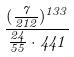<formula> <loc_0><loc_0><loc_500><loc_500>\frac { ( \frac { 7 } { 2 1 2 } ) ^ { 1 3 3 } } { \frac { 2 4 } { 5 5 } \cdot 4 4 1 }</formula> 